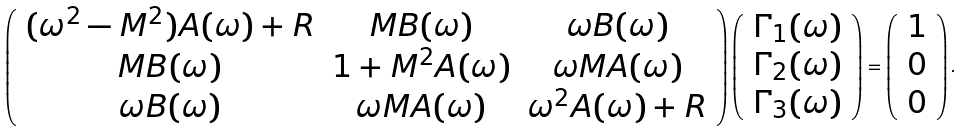Convert formula to latex. <formula><loc_0><loc_0><loc_500><loc_500>\left ( \begin{array} { c c c } ( \omega ^ { 2 } - M ^ { 2 } ) A ( \omega ) + R & M B ( \omega ) & \omega B ( \omega ) \\ M B ( \omega ) & 1 + M ^ { 2 } A ( \omega ) & \omega M A ( \omega ) \\ \omega B ( \omega ) & \omega M A ( \omega ) & \omega ^ { 2 } A ( \omega ) + R \end{array} \right ) \left ( \begin{array} { c } \Gamma _ { 1 } ( \omega ) \\ \Gamma _ { 2 } ( \omega ) \\ \Gamma _ { 3 } ( \omega ) \end{array} \right ) = \left ( \begin{array} { c } 1 \\ 0 \\ 0 \end{array} \right ) .</formula> 